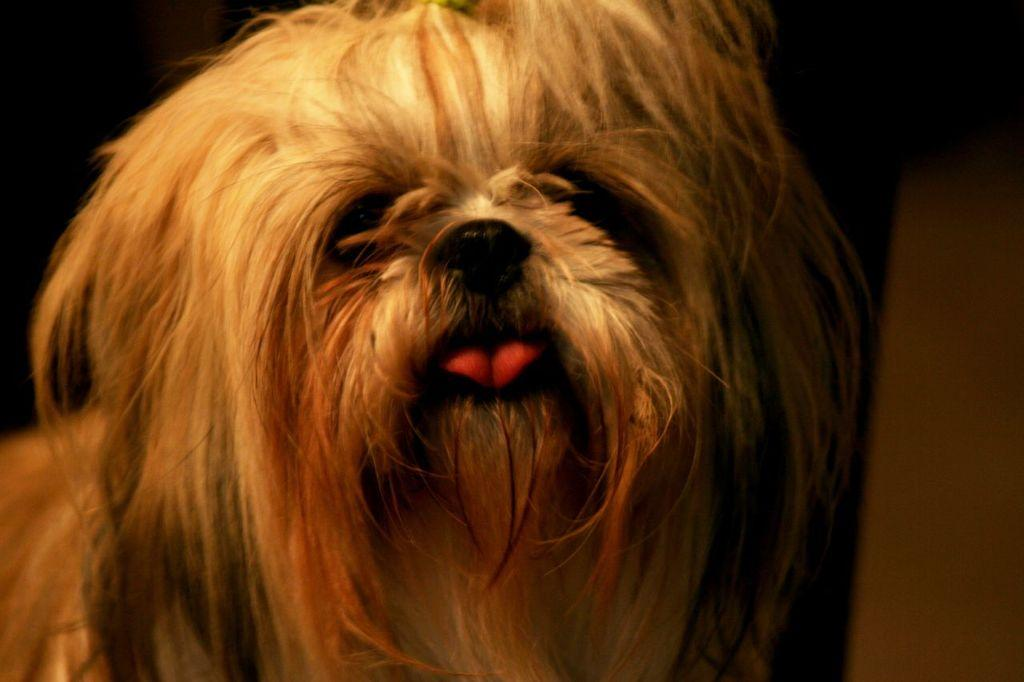What type of animal is in the picture? There is a dog in the picture. Can you describe the color of the dog? The dog is white and cream in color. What is the color of the background in the image? The background of the image is dark. How many babies are visible in the image? There are no babies present in the image; it features a dog. What type of flesh can be seen on the dog in the image? The dog is white and cream in color, so there is no visible flesh in the image. 